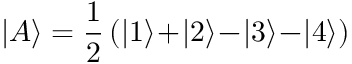<formula> <loc_0><loc_0><loc_500><loc_500>| A \rangle = \frac { 1 } { 2 } \, ( | 1 \rangle \, + \, | 2 \rangle \, - \, | 3 \rangle \, - \, | 4 \rangle )</formula> 